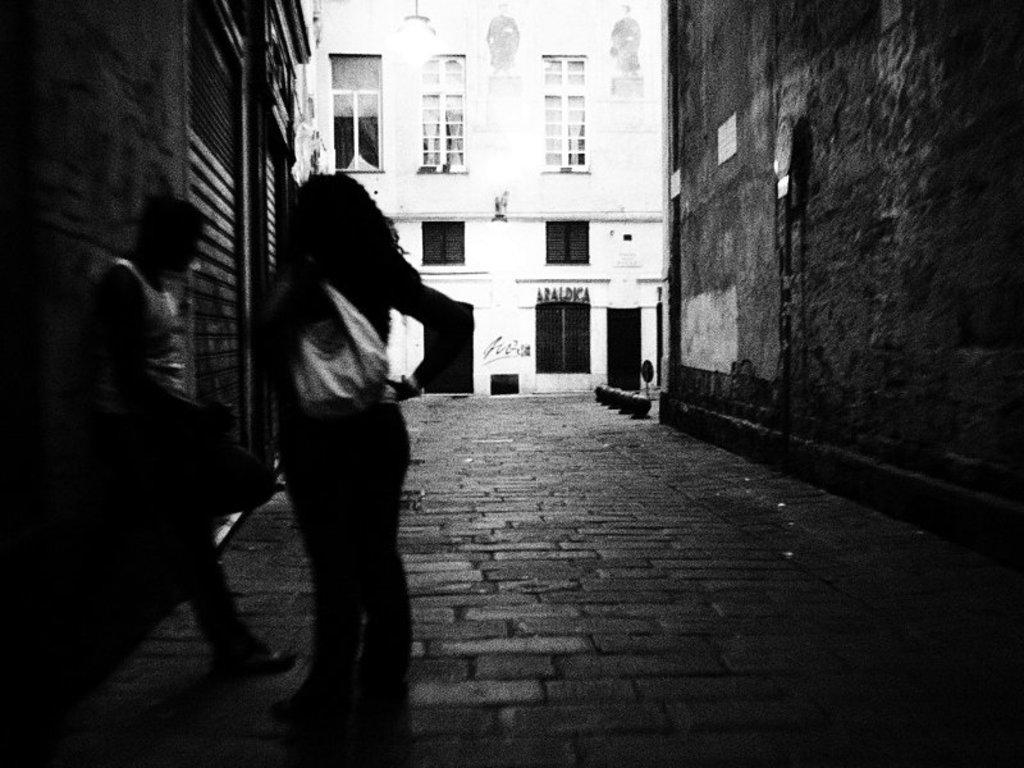What is the color scheme of the image? The image is black and white. What can be seen in the image? There is a person standing in the image. Where is the person standing in relation to other objects? The person is standing near a wall and on a road. What is visible in the background of the image? There is a building visible in the background of the image. What type of letters does the person have in their hands in the image? There are no letters visible in the person's hands in the image. How many pets can be seen in the image? There are no pets present in the image. 